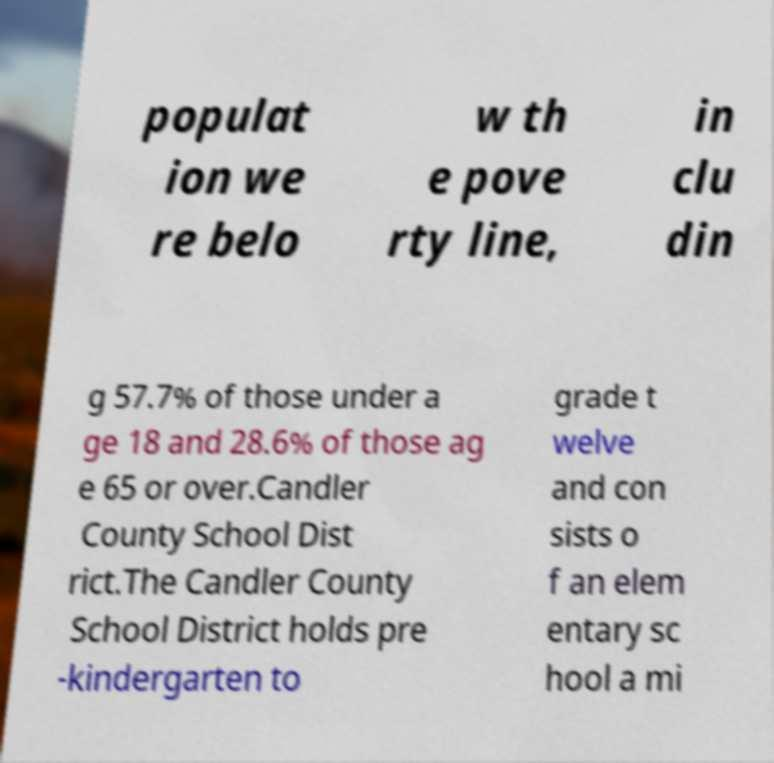Please read and relay the text visible in this image. What does it say? populat ion we re belo w th e pove rty line, in clu din g 57.7% of those under a ge 18 and 28.6% of those ag e 65 or over.Candler County School Dist rict.The Candler County School District holds pre -kindergarten to grade t welve and con sists o f an elem entary sc hool a mi 